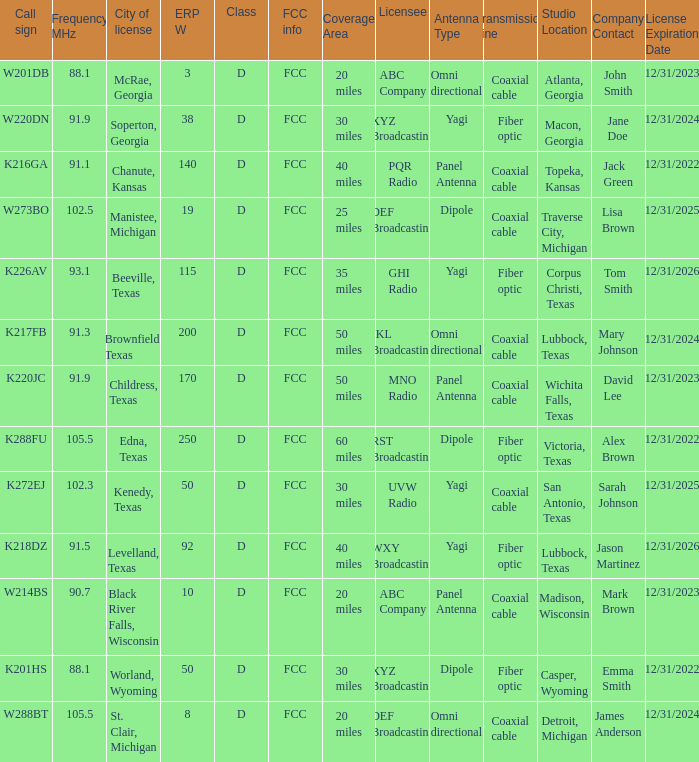What is City of License, when ERP W is greater than 3, and when Call Sign is K218DZ? Levelland, Texas. 